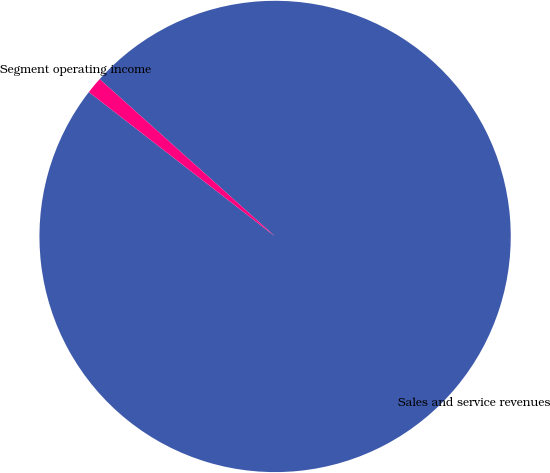<chart> <loc_0><loc_0><loc_500><loc_500><pie_chart><fcel>Sales and service revenues<fcel>Segment operating income<nl><fcel>98.86%<fcel>1.14%<nl></chart> 